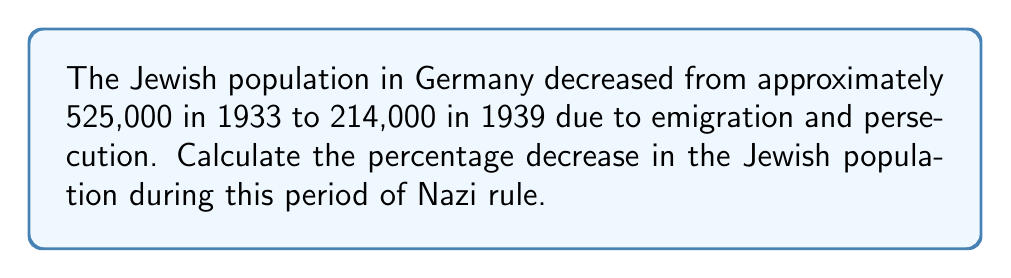Provide a solution to this math problem. To calculate the percentage decrease, we need to follow these steps:

1. Calculate the total decrease:
   $525,000 - 214,000 = 311,000$

2. Divide the decrease by the original population:
   $\frac{311,000}{525,000} = 0.5923809524$

3. Convert the decimal to a percentage by multiplying by 100:
   $0.5923809524 \times 100 = 59.23809524\%$

4. Round to two decimal places:
   $59.24\%$

Therefore, the percentage decrease in the Jewish population in Germany from 1933 to 1939 was approximately 59.24%.
Answer: $59.24\%$ 